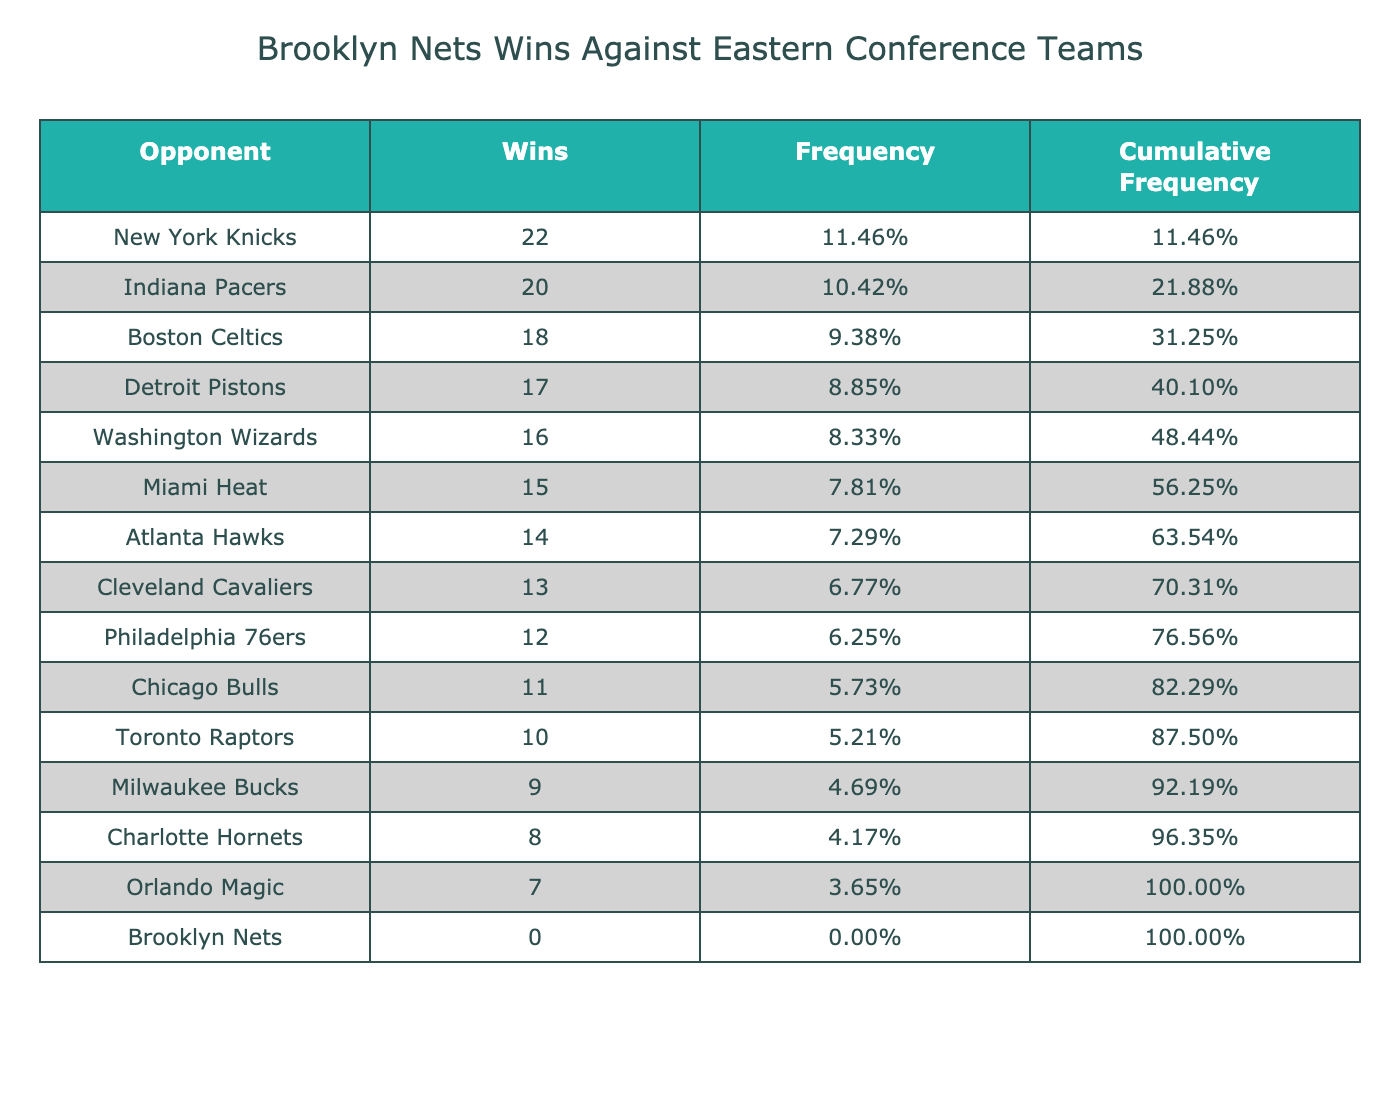What is the total number of wins by the Brooklyn Nets against Eastern Conference teams? The table shows that the Brooklyn Nets have 0 wins against Eastern Conference teams as indicated in the "Wins" column.
Answer: 0 Which team did the Brooklyn Nets win against the most in this table? The data shows that the Brooklyn Nets have 0 wins against all teams, so they did not win against any team.
Answer: None What is the frequency of wins against the New York Knicks? The New York Knicks have 22 wins according to the table. To find the frequency, we calculate the total wins by summing up all wins: 18 + 12 + 15 + 10 + 14 + 11 + 9 + 16 + 20 + 7 + 22 + 13 + 17 + 8 + 0 =  200. The frequency for the Knicks is 22/200, which is 0.11 or 11%.
Answer: 11% How many teams have more wins than the Atlanta Hawks? The Atlanta Hawks have 14 wins. Looking at the wins column, we see the following teams have more wins: Indiana Pacers (20), New York Knicks (22), Boston Celtics (18), Philadelphia 76ers (12), and other teams with equal or fewer wins. Count: 6 teams have more wins than the Hawks.
Answer: 6 What is the average number of wins among the Eastern Conference teams listed? To find the average, we first sum the wins of all teams: 18 + 12 + 15 + 10 + 14 + 11 + 9 + 16 + 20 + 7 + 22 + 13 + 17 + 8 + 0 =  200. There are 15 teams in total. The average is calculated as 200/15, which equals approximately 13.33.
Answer: 13.33 Is it true that the Brooklyn Nets won against any Eastern Conference teams? Based on the table, the Brooklyn Nets have 0 wins against all listed teams. This confirms that they did not win against any team.
Answer: No Which team has the least number of wins, and how many do they have? The Orlando Magic has the least number of wins at 7, as seen in the "Wins" column under the respective opponent row.
Answer: Orlando Magic, 7 What is the cumulative frequency for the Indiana Pacers? The Indiana Pacers have 20 wins. First, we find the total wins, which is 200. The frequency for the Pacers is calculated as 20/200 = 0.10 or 10%. Since this is the 9th entry when listing teams in order of wins, we add up the frequencies of all previous teams: 18 + 12 + 15 + 10 + 14 + 11 + 9 + 16 + 20/200 = 0.10 + 0.09 + 0.07 + 0.05 + 0.03 + 0.04 + 0.04 + 0.08 + 0.05 = 0.45, making the cumulative frequency for the Indiana Pacers 0.55 or 55%.
Answer: 55% 